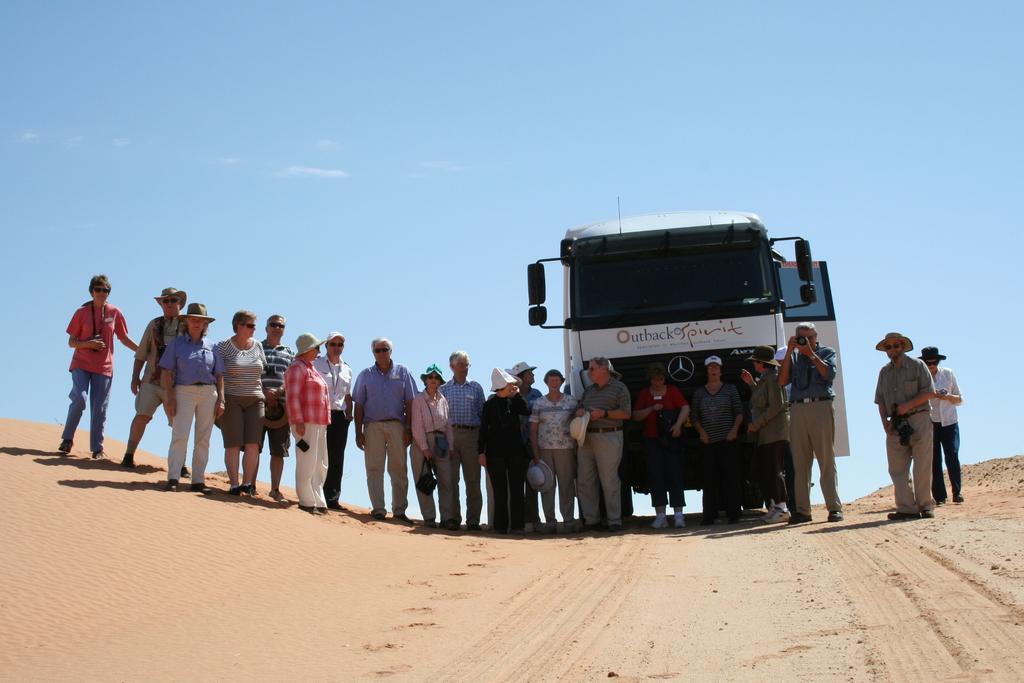How would you summarize this image in a sentence or two? In the image we can see there are people standing on the ground and there is sand on the ground. Behind the people there is a vehicle parked on the ground and there are few people wearing hats. The sky is clear. 